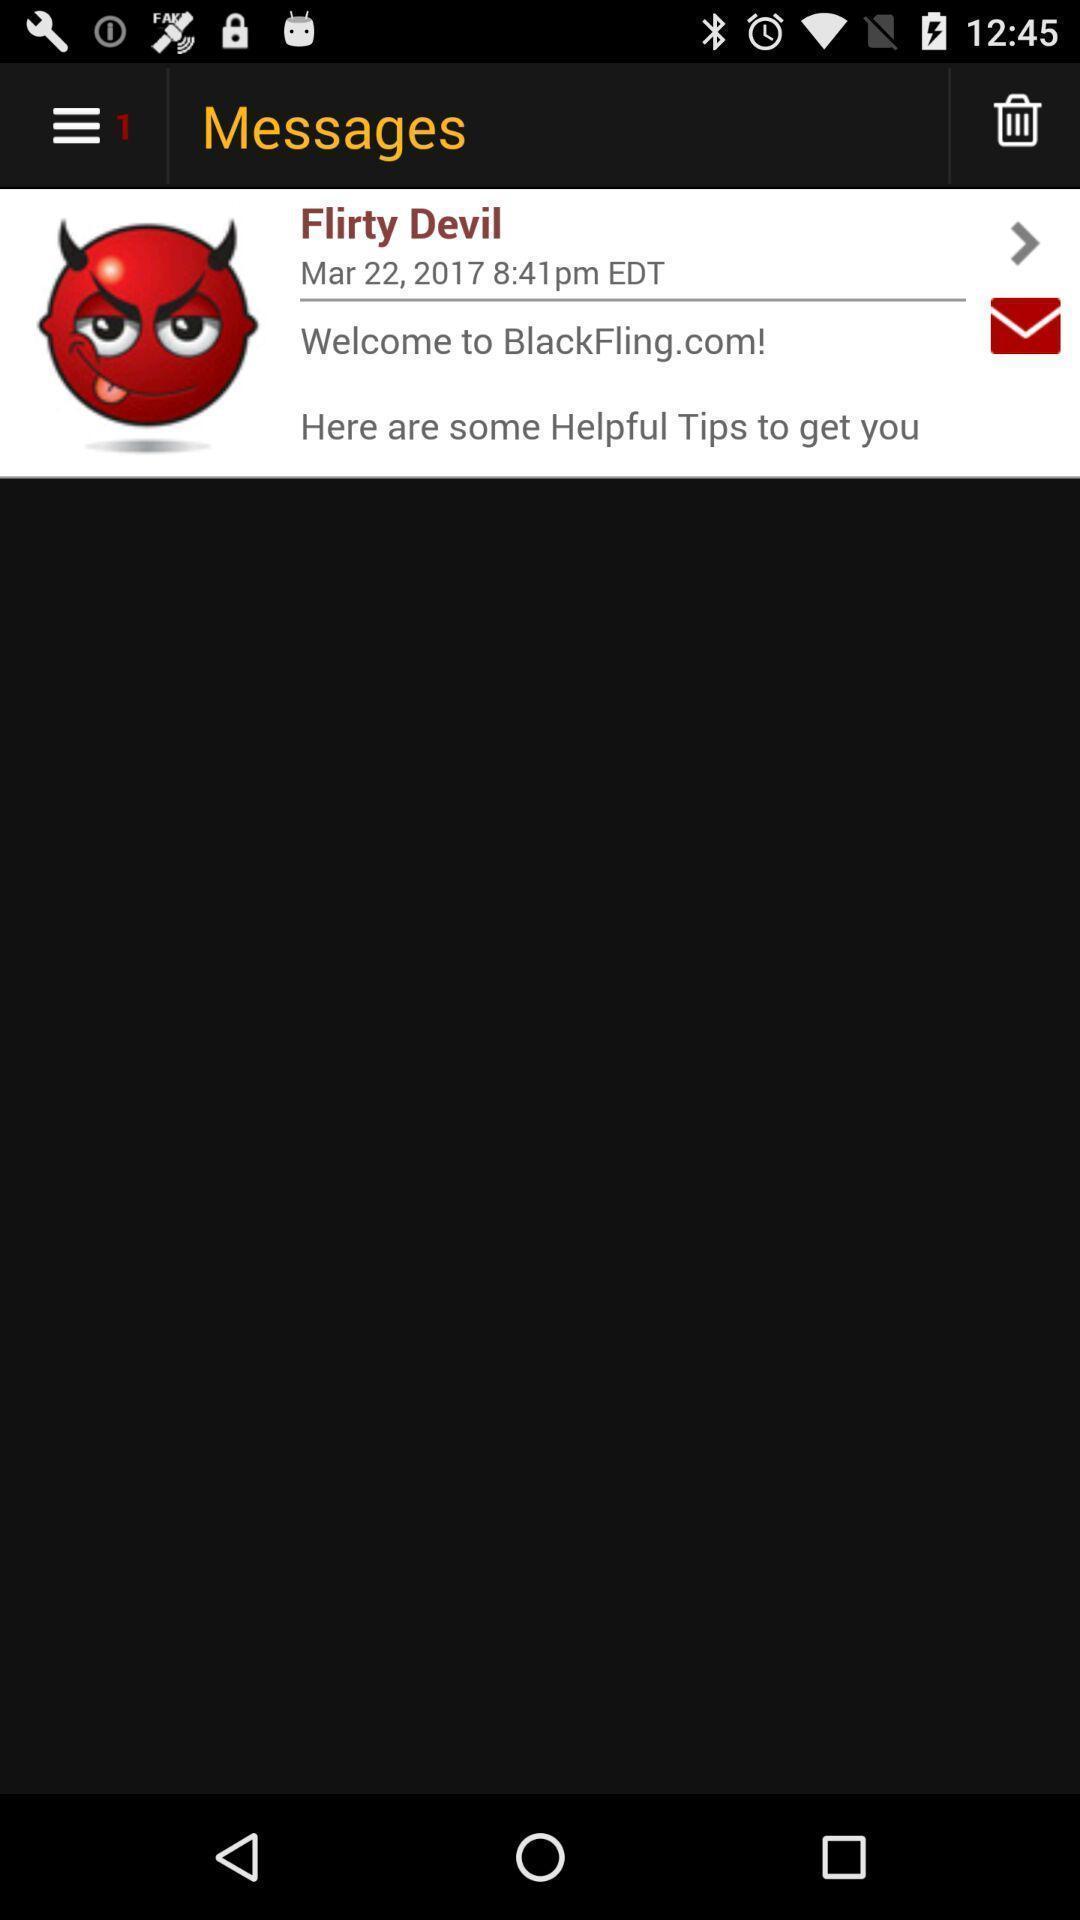Describe the content in this image. Screen displaying messages. 